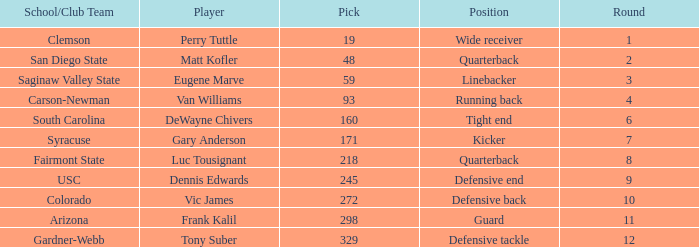Who plays linebacker? Eugene Marve. 